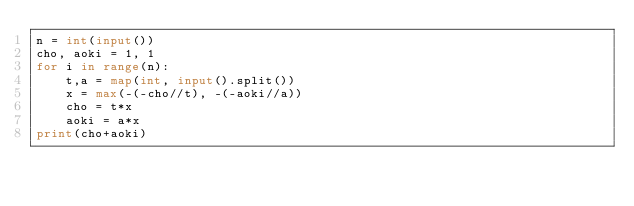Convert code to text. <code><loc_0><loc_0><loc_500><loc_500><_Python_>n = int(input())
cho, aoki = 1, 1
for i in range(n):
    t,a = map(int, input().split())
    x = max(-(-cho//t), -(-aoki//a))
    cho = t*x
    aoki = a*x
print(cho+aoki)</code> 